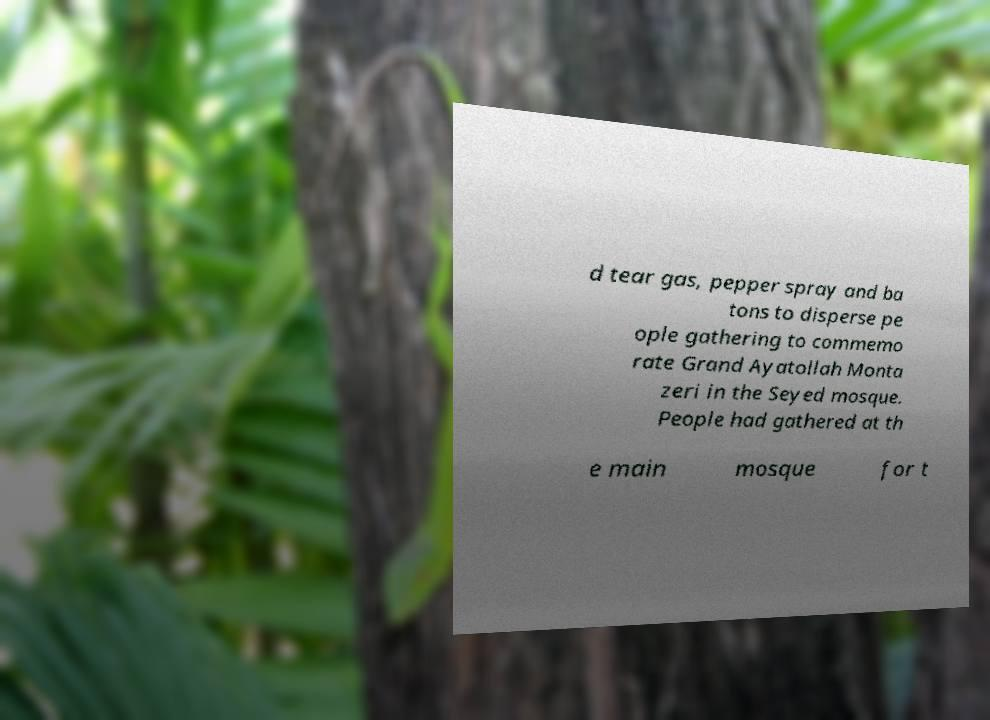Can you read and provide the text displayed in the image?This photo seems to have some interesting text. Can you extract and type it out for me? d tear gas, pepper spray and ba tons to disperse pe ople gathering to commemo rate Grand Ayatollah Monta zeri in the Seyed mosque. People had gathered at th e main mosque for t 